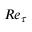Convert formula to latex. <formula><loc_0><loc_0><loc_500><loc_500>R e _ { \tau }</formula> 